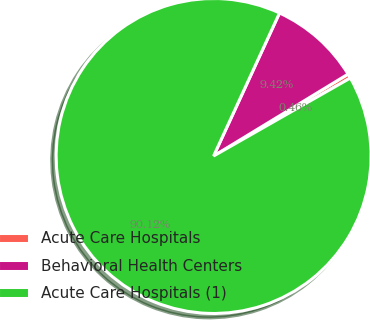Convert chart. <chart><loc_0><loc_0><loc_500><loc_500><pie_chart><fcel>Acute Care Hospitals<fcel>Behavioral Health Centers<fcel>Acute Care Hospitals (1)<nl><fcel>0.46%<fcel>9.42%<fcel>90.12%<nl></chart> 